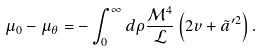Convert formula to latex. <formula><loc_0><loc_0><loc_500><loc_500>\mu _ { 0 } - \mu _ { \theta } = - \int _ { 0 } ^ { \infty } d \rho \frac { \mathcal { M } ^ { 4 } } { \mathcal { L } } \left ( 2 v + \tilde { a } ^ { \prime 2 } \right ) .</formula> 